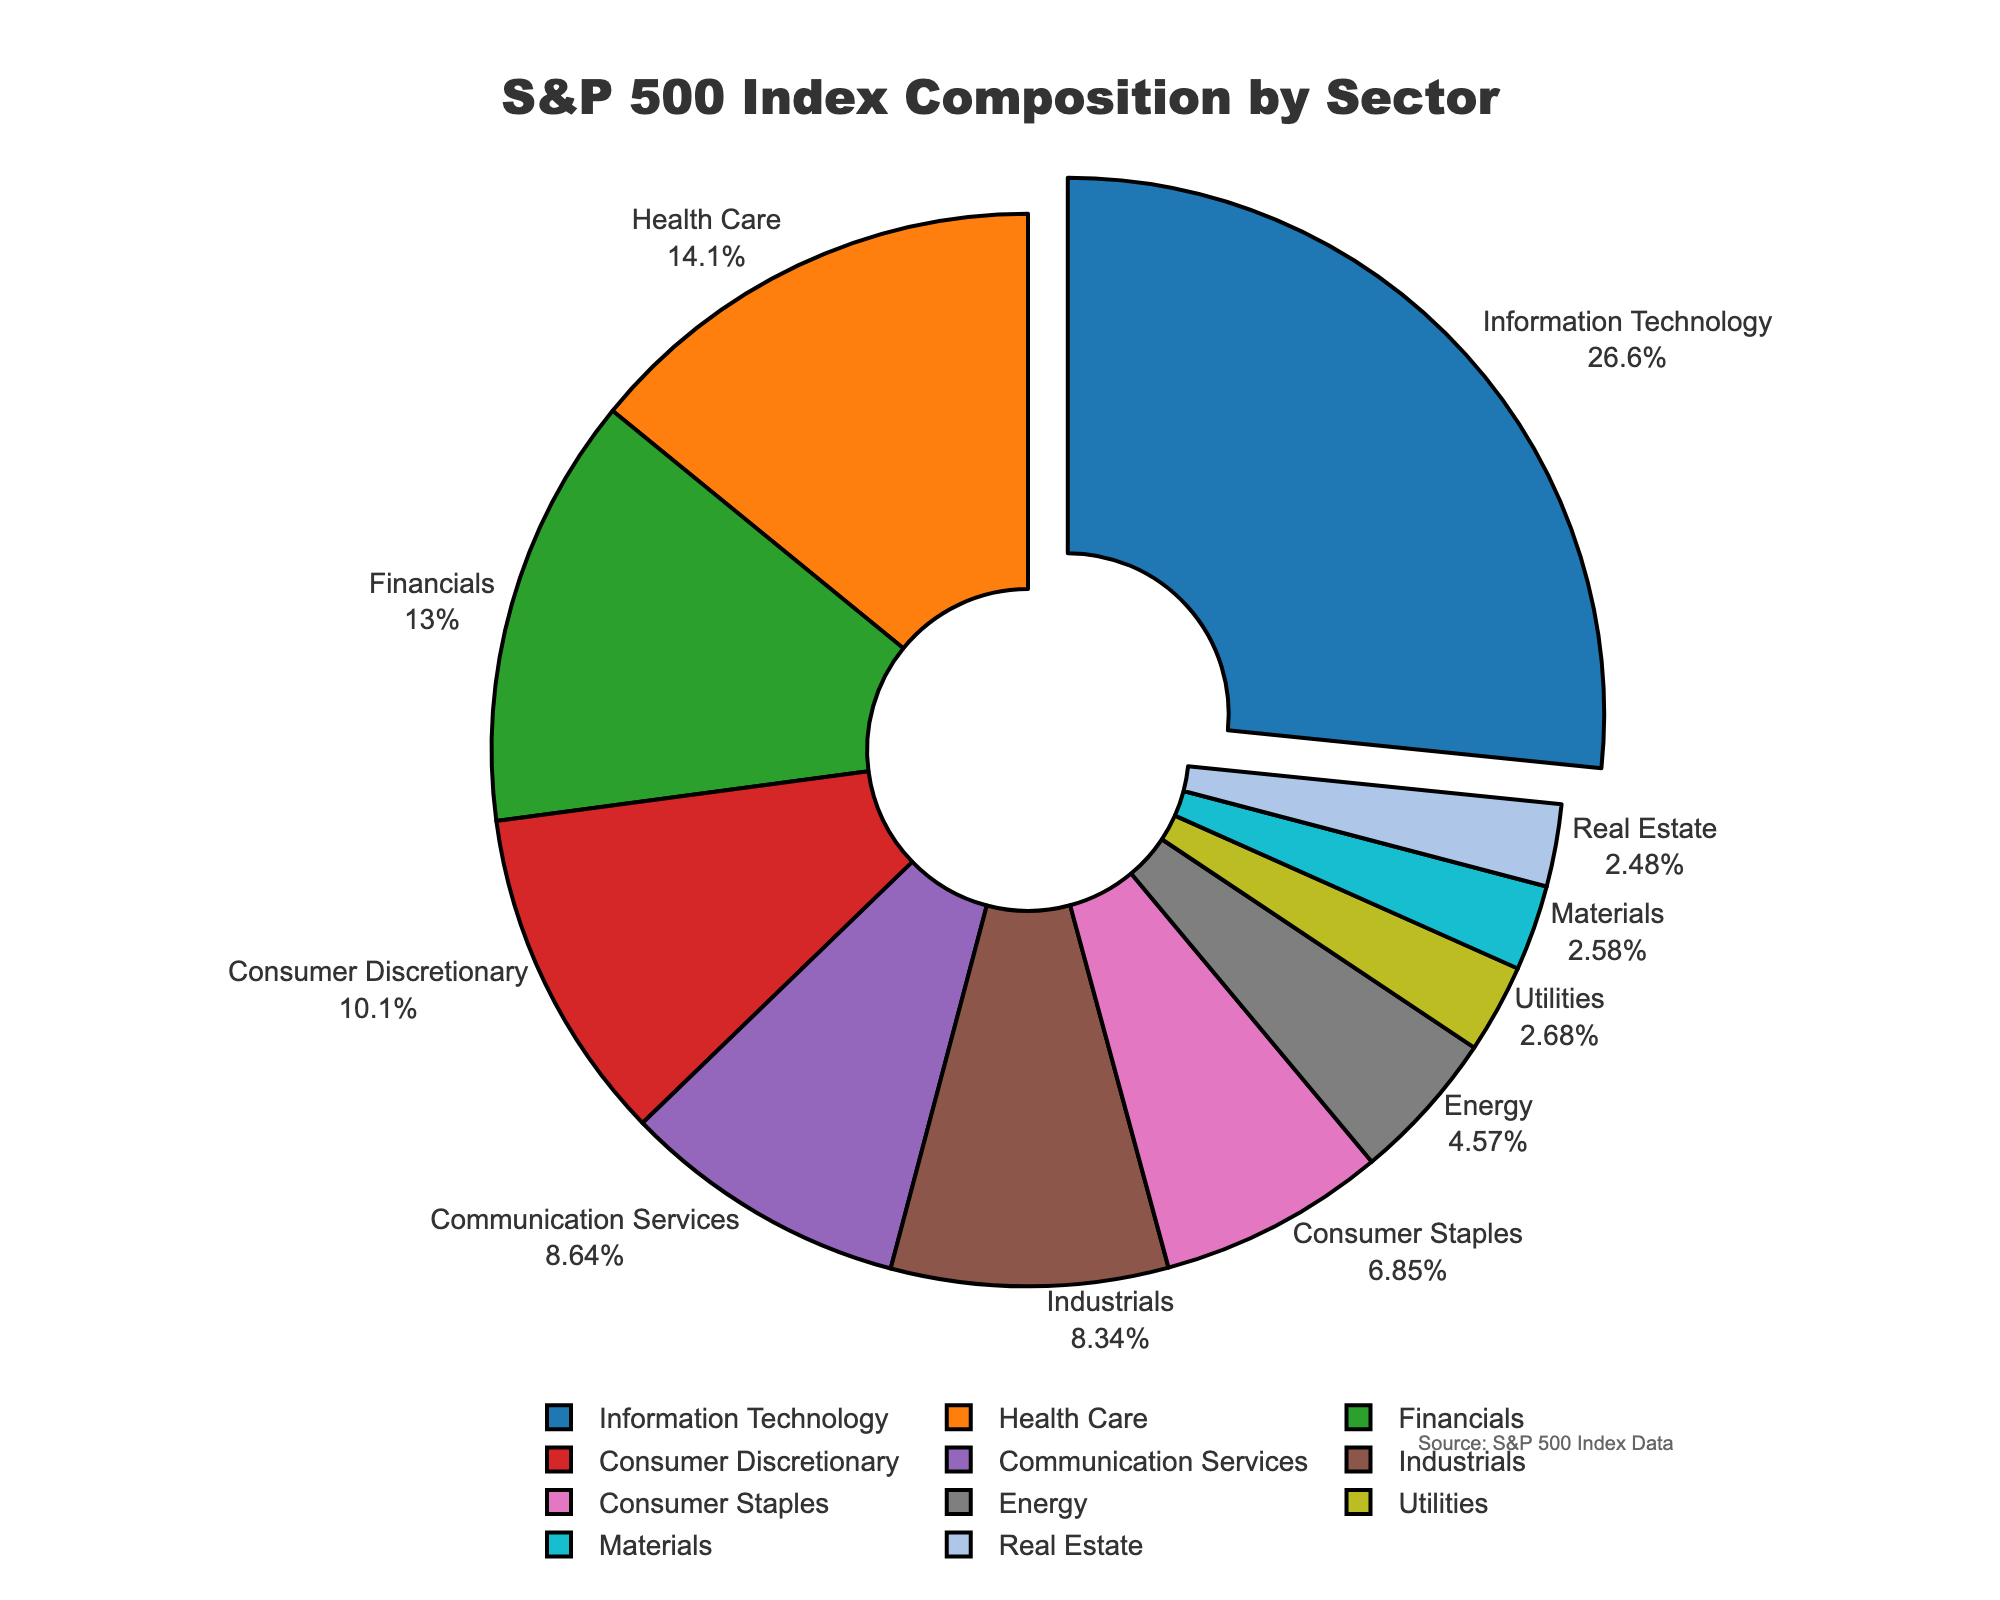What percentage of the S&P 500 index is made up by the Consumer Discretionary and Consumer Staples sectors combined? Adding the percentages of the Consumer Discretionary sector (10.2%) and the Consumer Staples sector (6.9%), we get 17.1%.
Answer: 17.1% Which sector has the highest composition in the S&P 500 index? Looking at the pie chart, the Information Technology sector has the largest slice, indicating it has the highest composition at 26.8%.
Answer: Information Technology How much larger is the Health Care sector compared to the Real Estate sector? The percentage of the Health Care sector is 14.2% and the Real Estate sector is 2.5%. Subtracting these, 14.2% - 2.5% = 11.7%.
Answer: 11.7% Which sectors in the S&P 500 index have a composition lower than 5%? Sectors with a composition lower than 5% are Energy (4.6%), Utilities (2.7%), Materials (2.6%), and Real Estate (2.5%).
Answer: Energy, Utilities, Materials, Real Estate What is the combined percentage of the three smallest sectors in the index? The three smallest sectors are Real Estate (2.5%), Materials (2.6%), and Utilities (2.7%). Adding these gives us 2.5% + 2.6% + 2.7% = 7.8%.
Answer: 7.8% Which sector's slice is pulled out from the pie chart, and why might it be pulled out? The slice for Information Technology is pulled out from the pie chart. This highlights the sector as it has the highest percentage composition in the S&P 500 index at 26.8%.
Answer: Information Technology How does the Financials sector compare to the Health Care sector in terms of percentage composition? The Financials sector has a composition of 13.1%, while the Health Care sector has 14.2%. Therefore, the Health Care sector is larger.
Answer: Health Care is larger What is the median value of the sector percentages shown in the pie chart? To find the median, we list the percentages in ascending order and find the middle value. The sorted percentages are: 2.5, 2.6, 2.7, 4.6, 6.9, 8.4, 8.7, 10.2, 13.1, 14.2, 26.8. The middle value (6th) is 8.4%.
Answer: 8.4% If we combined the percentages of the top two sectors, what percentage of the S&P 500 would they represent? The top two sectors are Information Technology (26.8%) and Health Care (14.2%). Their combined percentage is 26.8% + 14.2% = 41%.
Answer: 41% What color is used to represent the Energy sector in the pie chart? The Energy sector is represented by a specific color in the pie chart. By visually checking, it is the 8th slice in the sequence of colors provided. The corresponding color for Energy is blackish grey.
Answer: Blackish grey 